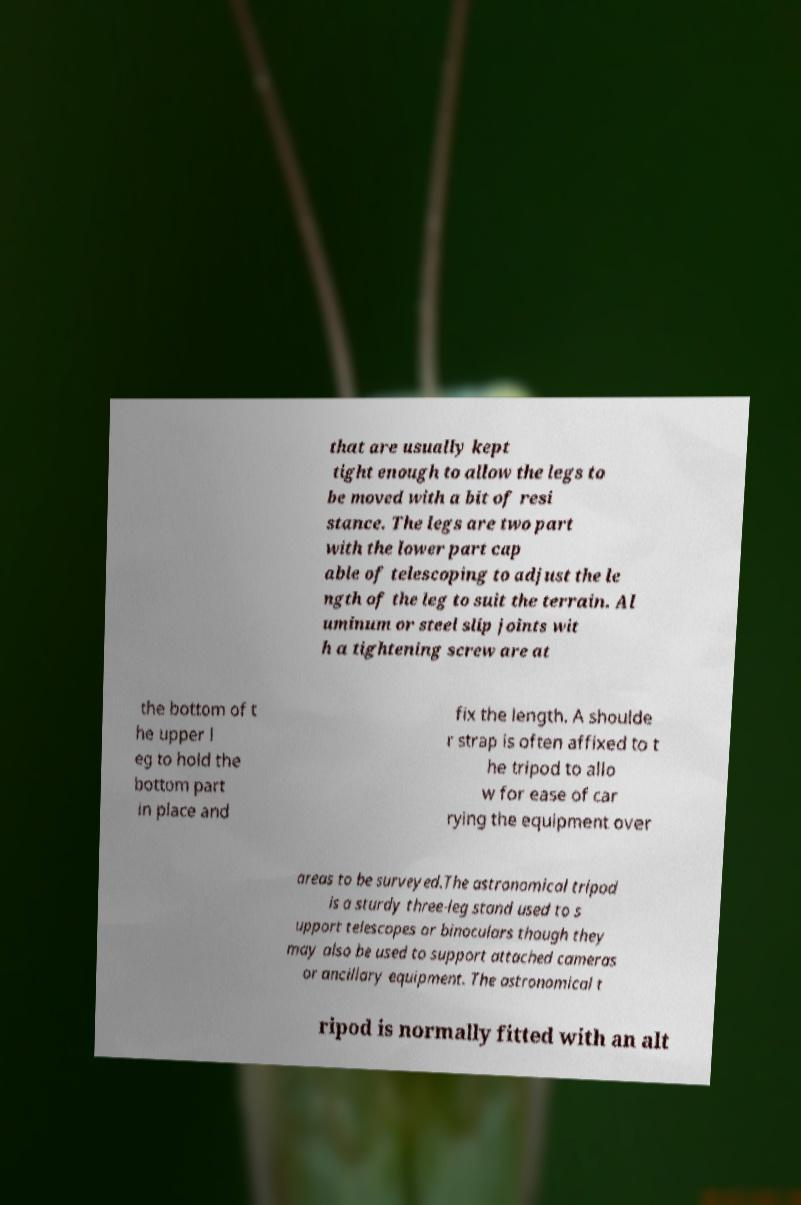Please identify and transcribe the text found in this image. that are usually kept tight enough to allow the legs to be moved with a bit of resi stance. The legs are two part with the lower part cap able of telescoping to adjust the le ngth of the leg to suit the terrain. Al uminum or steel slip joints wit h a tightening screw are at the bottom of t he upper l eg to hold the bottom part in place and fix the length. A shoulde r strap is often affixed to t he tripod to allo w for ease of car rying the equipment over areas to be surveyed.The astronomical tripod is a sturdy three-leg stand used to s upport telescopes or binoculars though they may also be used to support attached cameras or ancillary equipment. The astronomical t ripod is normally fitted with an alt 